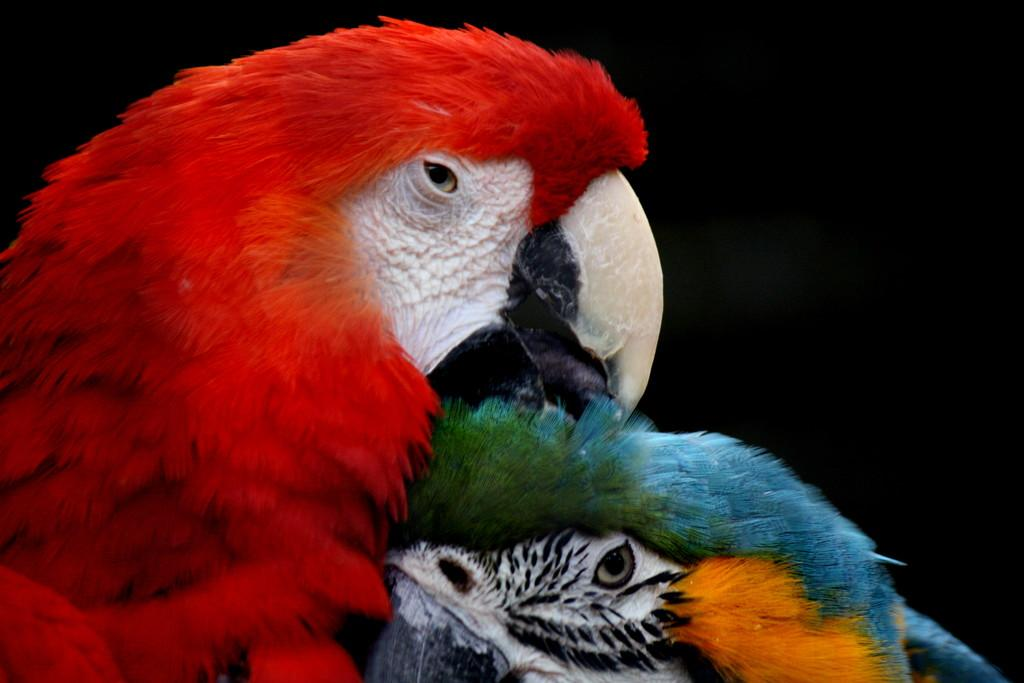What type of animal is in the image? There is a parrot in the image. What color is the parrot? The parrot is red in color. On which side of the image is the parrot located? The parrot is on the left side of the image. Are there any other birds in the image? Yes, there is another bird in the image. What color is the other bird? The other bird is blue in color. On which side of the image is the other bird located? The other bird is on the right side of the image. What type of coil can be seen in the image? There is no coil present in the image; it features two birds, a red parrot and a blue bird. 